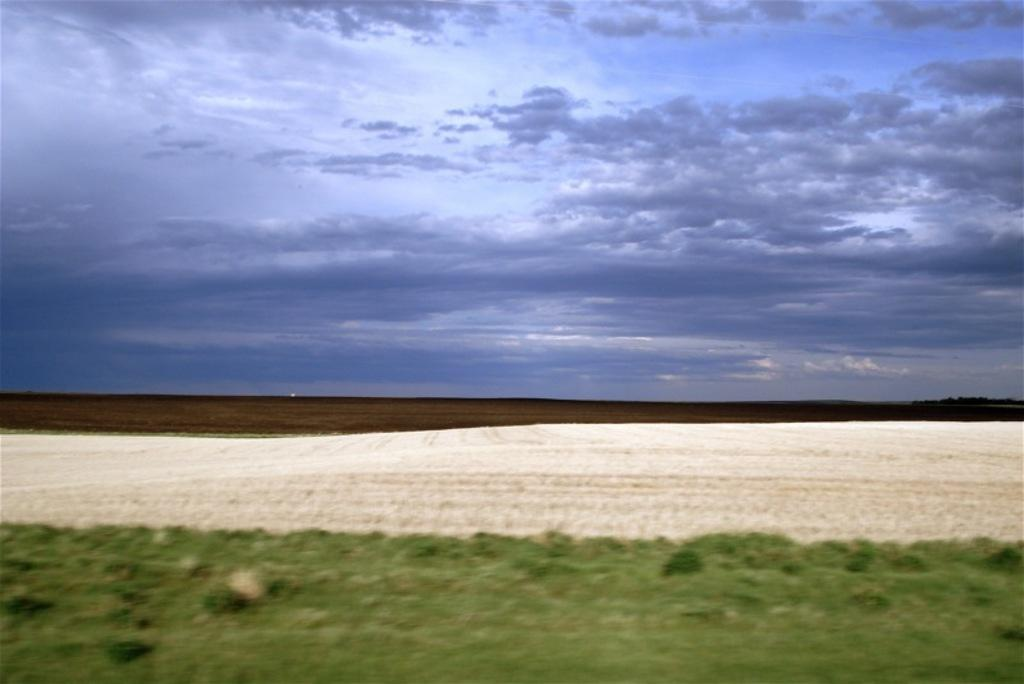What is visible at the bottom of the image? Grass is present at the bottom of the image. What is visible in the background of the image? The sky and trees are visible in the background of the image. What is the condition of the sky in the image? The sky appears to be cloudy in the image. What type of terrain is visible in the image? The ground is visible in the image, which includes grass. Can you see a kitten playing with a piece of wood in the image? There is no kitten or piece of wood present in the image. What is the best way to reach the top of the trees in the image? The image does not provide information on how to reach the top of the trees, nor does it suggest that reaching the top is necessary or possible. 